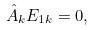Convert formula to latex. <formula><loc_0><loc_0><loc_500><loc_500>\hat { A } _ { k } E _ { 1 k } = 0 ,</formula> 